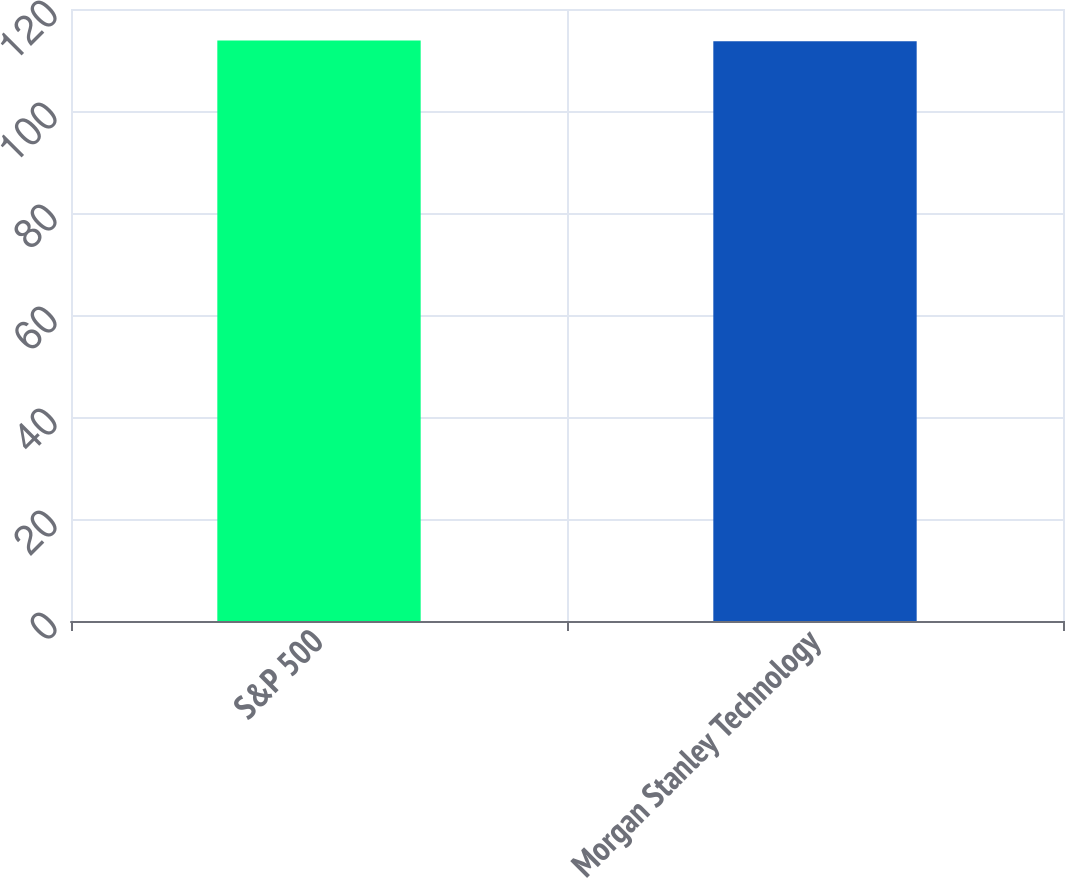<chart> <loc_0><loc_0><loc_500><loc_500><bar_chart><fcel>S&P 500<fcel>Morgan Stanley Technology<nl><fcel>113.83<fcel>113.68<nl></chart> 